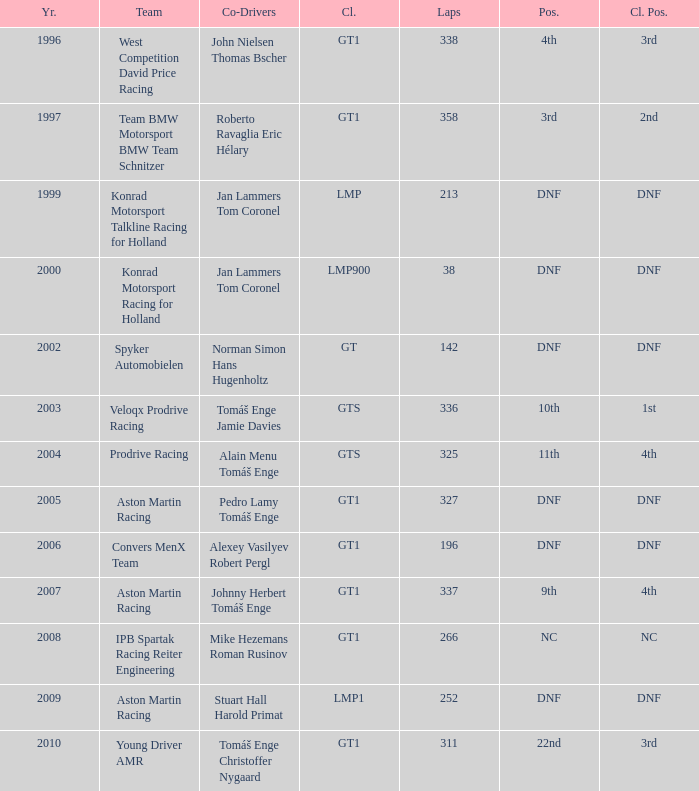In which category did 252 laps occur and a position of dnf? LMP1. 